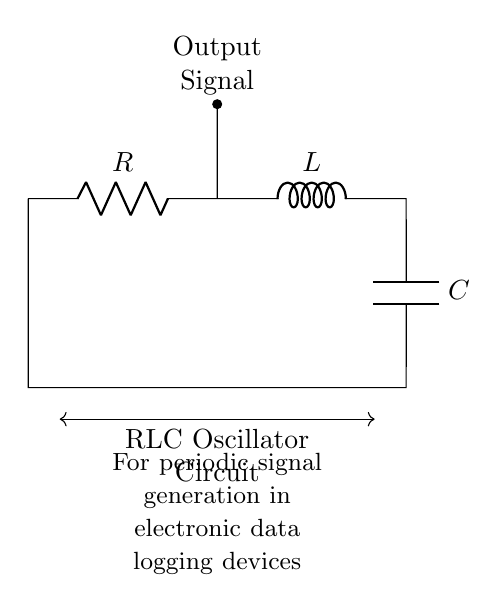What are the components in this circuit? The components in the circuit are a resistor, an inductor, and a capacitor. These can be directly identified from the labels on the circuit diagram.
Answer: Resistor, Inductor, Capacitor What is the purpose of the output signal? The output signal, indicated in the circuit, is used for generating periodic signals in the electronic data logging devices, as noted in the circuit description.
Answer: Periodic signal generation How many components are in the circuit? There are three main components in this RLC circuit: the resistor, inductor, and capacitor. This can be counted directly from the diagram.
Answer: Three What type of circuit is this? This is an RLC oscillator circuit. The name is derived from the combination of resistor, inductor, and capacitor used to generate oscillations.
Answer: RLC oscillator circuit What is the connection between the resistor and inductor? The resistor is connected in series with the inductor. This is indicated by the straight line connecting them in the circuit diagram.
Answer: Series connection How does the RLC circuit generate periodic signals? The RLC circuit generates periodic signals through the oscillations of energy between the inductor and capacitor, while the resistor controls the oscillation's damping. This is a fundamental characteristic of RLC circuits.
Answer: Through oscillations of energy What role does the capacitor play in this circuit? The capacitor stores and releases energy, which helps create the oscillating behavior of the circuit. This energy exchange between the capacitor and the inductor leads to the generation of periodic signals.
Answer: Stores and releases energy 